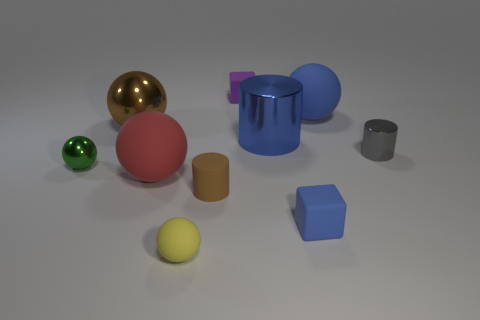Subtract all large blue balls. How many balls are left? 4 Subtract all red spheres. How many spheres are left? 4 Subtract 3 spheres. How many spheres are left? 2 Subtract all cylinders. How many objects are left? 7 Subtract all cyan blocks. Subtract all brown spheres. How many blocks are left? 2 Subtract all blue things. Subtract all small cubes. How many objects are left? 5 Add 9 blue balls. How many blue balls are left? 10 Add 3 tiny rubber cylinders. How many tiny rubber cylinders exist? 4 Subtract 1 blue cubes. How many objects are left? 9 